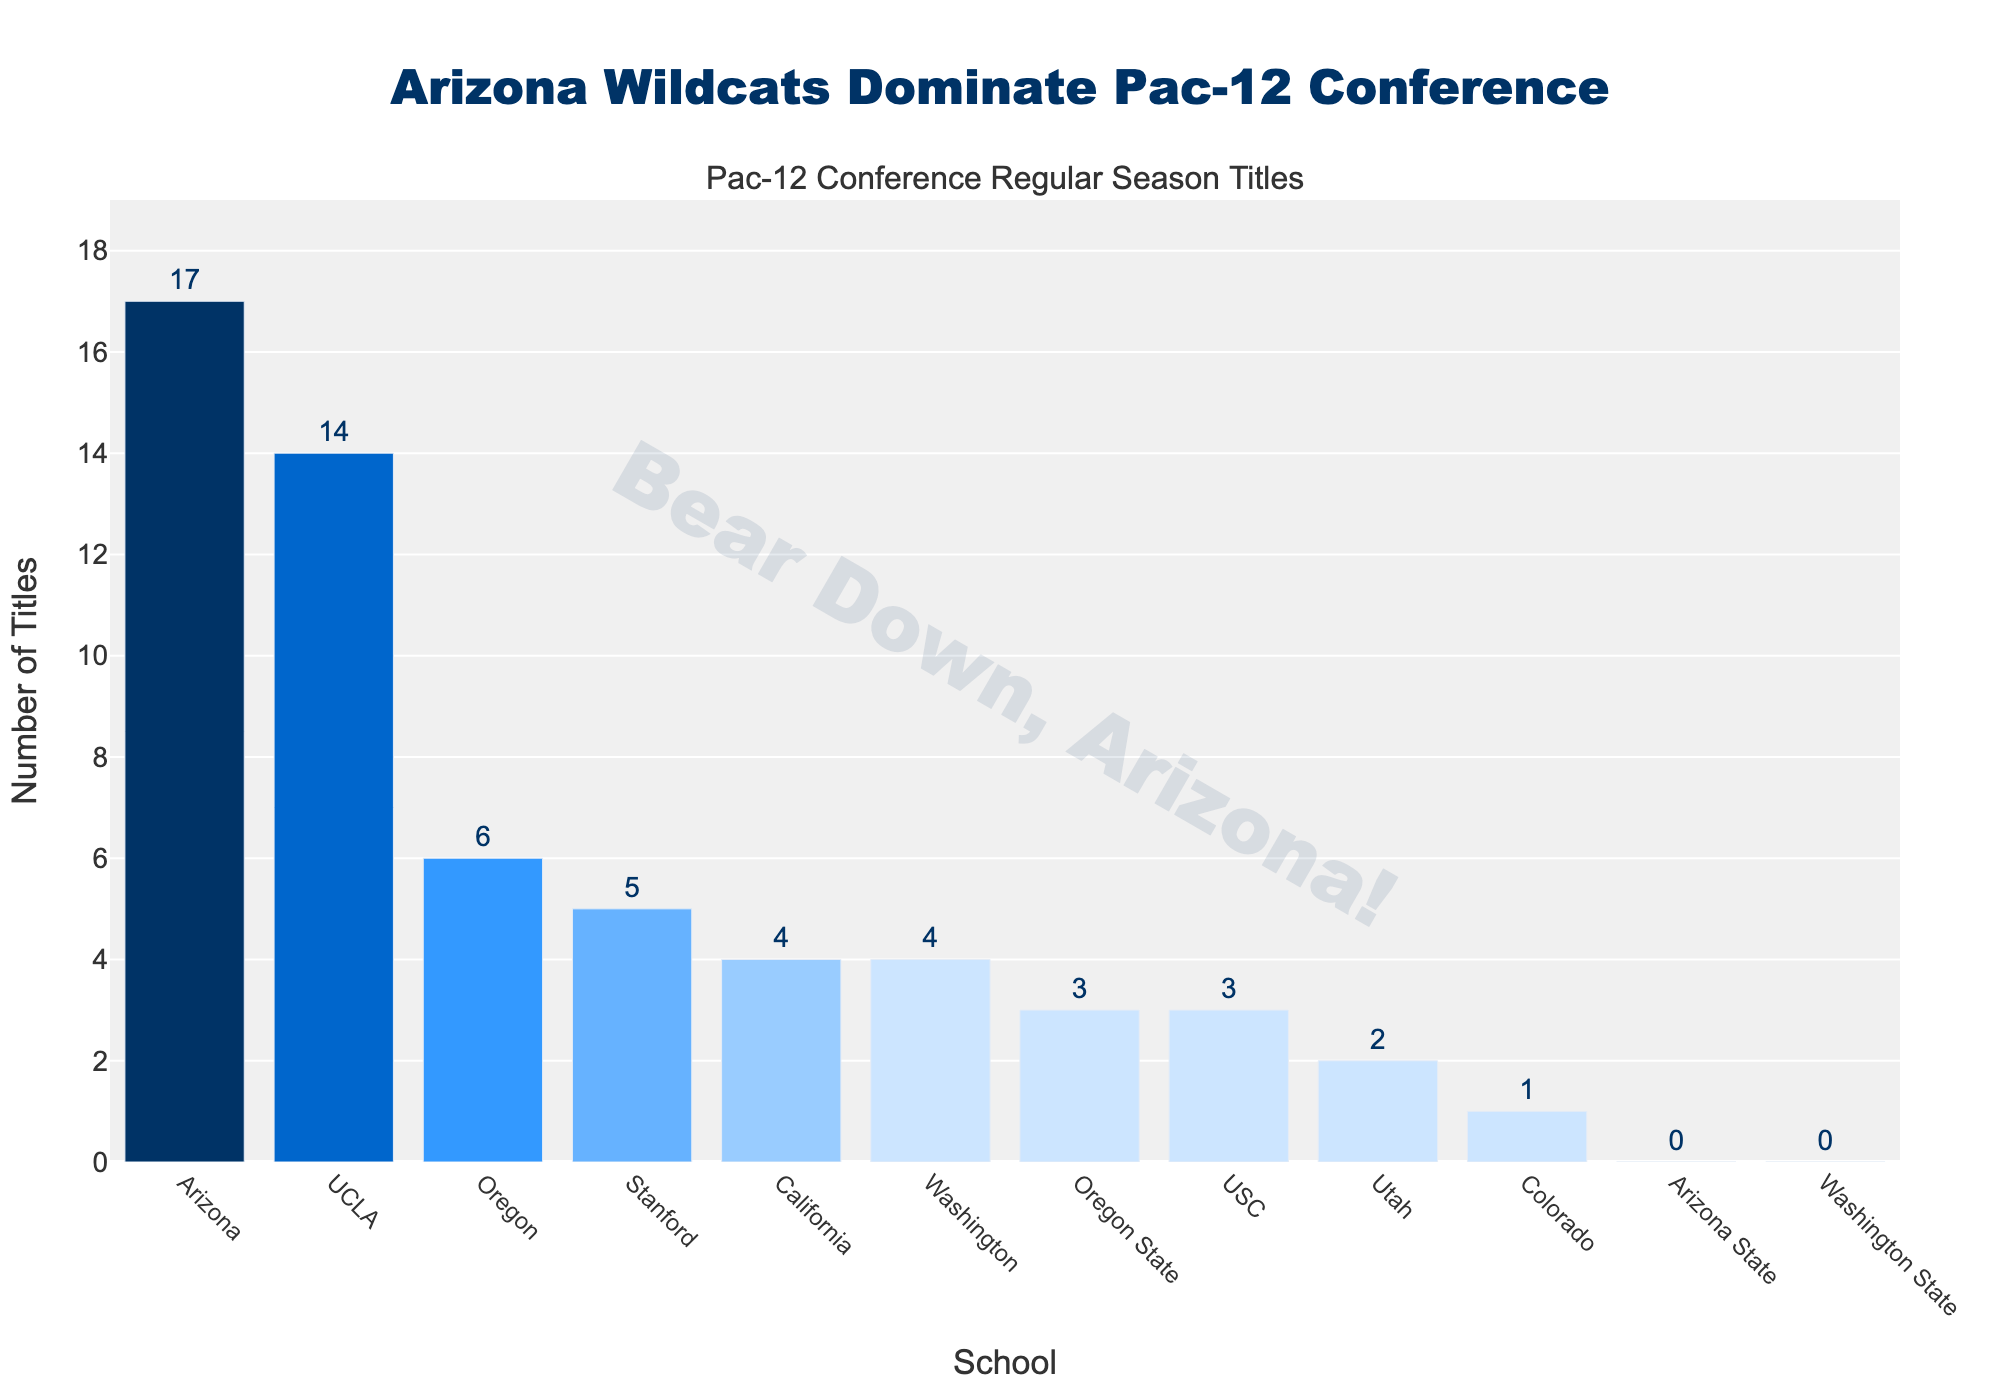What's the total number of Pac-12 regular season titles won by Arizona, UCLA, and Oregon? Add the number of titles won by each of the three schools: Arizona (17) + UCLA (14) + Oregon (6) = 37
Answer: 37 Which school has won the second-highest number of Pac-12 regular season titles? Compare the number of titles across all schools: Arizona (17), UCLA (14), and others with fewer titles. UCLA has the second-highest number of titles.
Answer: UCLA How many more Pac-12 titles has Arizona won compared to Stanford? Subtract the number of titles won by Stanford from those won by Arizona: Arizona (17) - Stanford (5) = 12
Answer: 12 Which school has won the fewest Pac-12 regular season titles? Identify the schools with zero titles from the chart: Arizona State and Washington State each have zero titles.
Answer: Arizona State, Washington State What is the combined number of Pac-12 regular season titles won by all California schools? Sum the titles of California schools: UCLA (14) + Stanford (5) + California (4) + USC (3) = 26
Answer: 26 What is the difference in the number of Pac-12 titles between the team with the highest and the team with the lowest number of titles? Subtract the titles of the schools with the highest (Arizona, 17) from those with the lowest (Arizona State and Washington State, 0): 17 - 0 = 17
Answer: 17 Which schools have won more Pac-12 regular season titles than Oregon State? Compare each school's total to Oregon State's (3): Arizona (17), UCLA (14), Oregon (6), Stanford (5), California (4), Washington (4)
Answer: Arizona, UCLA, Oregon, Stanford, California, Washington What's the average number of Pac-12 regular season titles won by all schools? Divide the total number of titles by the number of schools. Total titles = 59. Number of schools = 12. Average = 59 / 12 ≈ 4.92
Answer: 4.92 Which school has won exactly two Pac-12 regular season titles? Identify the school with two titles from the chart: Utah
Answer: Utah 